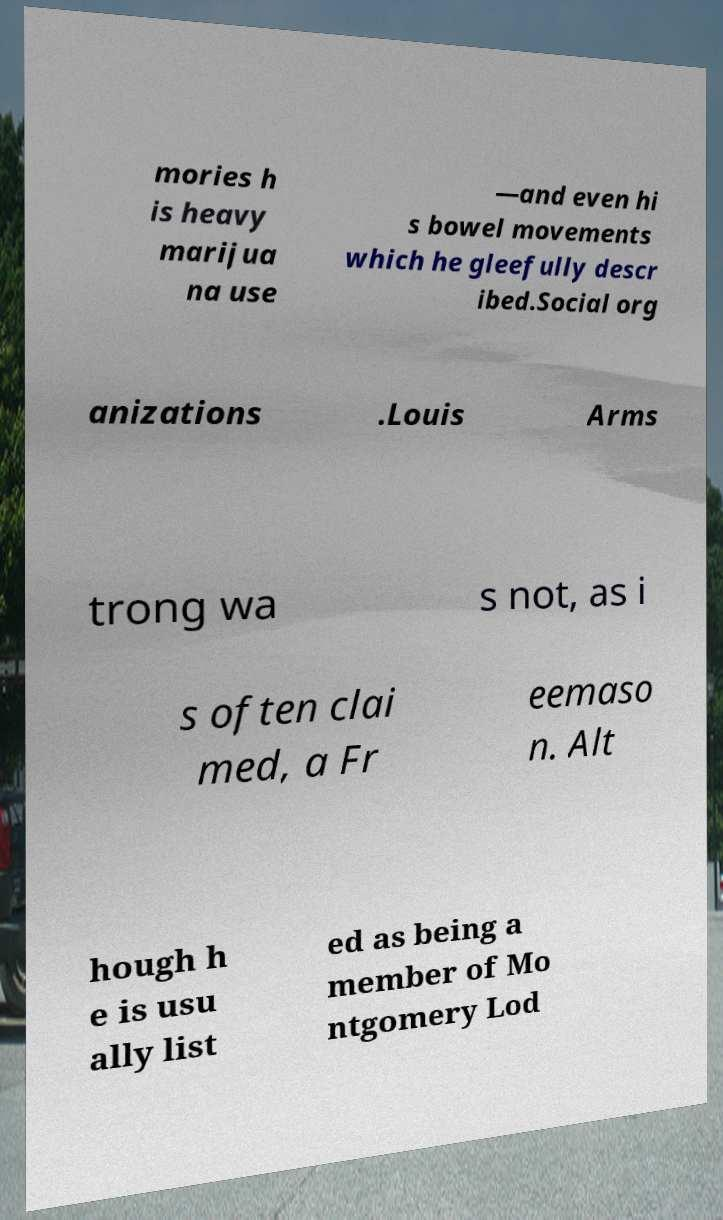I need the written content from this picture converted into text. Can you do that? mories h is heavy marijua na use —and even hi s bowel movements which he gleefully descr ibed.Social org anizations .Louis Arms trong wa s not, as i s often clai med, a Fr eemaso n. Alt hough h e is usu ally list ed as being a member of Mo ntgomery Lod 